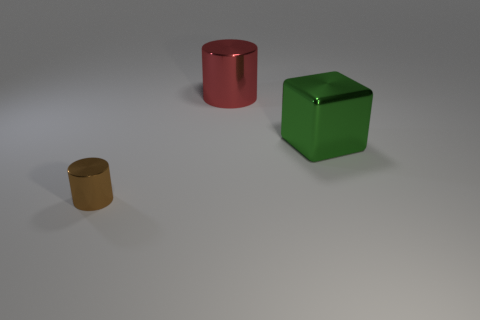Does the large metal block have the same color as the tiny cylinder?
Provide a succinct answer. No. How many small metal things are right of the big green metal object?
Your answer should be very brief. 0. What color is the other small metal thing that is the same shape as the red shiny thing?
Provide a succinct answer. Brown. Is the cylinder that is on the left side of the big red cylinder made of the same material as the cylinder that is on the right side of the small brown cylinder?
Give a very brief answer. Yes. There is a small thing; is its color the same as the large object that is on the right side of the large red cylinder?
Give a very brief answer. No. The object that is in front of the big red cylinder and behind the brown metal cylinder has what shape?
Ensure brevity in your answer.  Cube. How many big green shiny cubes are there?
Provide a short and direct response. 1. There is another object that is the same shape as the large red thing; what size is it?
Make the answer very short. Small. There is a large thing behind the metal block; does it have the same shape as the large green metal object?
Make the answer very short. No. There is a large object that is to the right of the red metal cylinder; what color is it?
Keep it short and to the point. Green. 